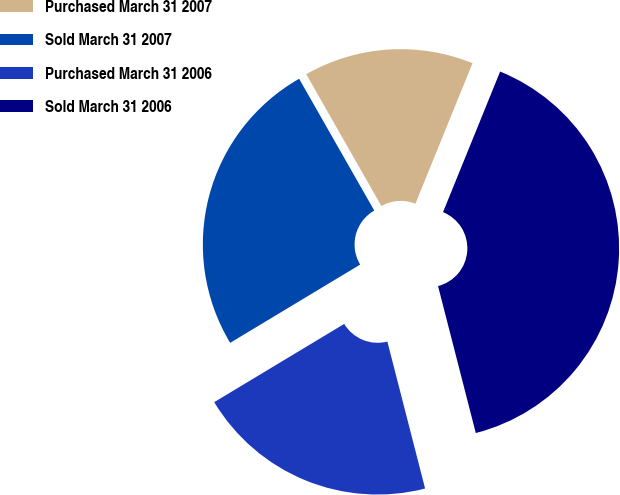<chart> <loc_0><loc_0><loc_500><loc_500><pie_chart><fcel>Purchased March 31 2007<fcel>Sold March 31 2007<fcel>Purchased March 31 2006<fcel>Sold March 31 2006<nl><fcel>14.39%<fcel>25.38%<fcel>20.38%<fcel>39.86%<nl></chart> 